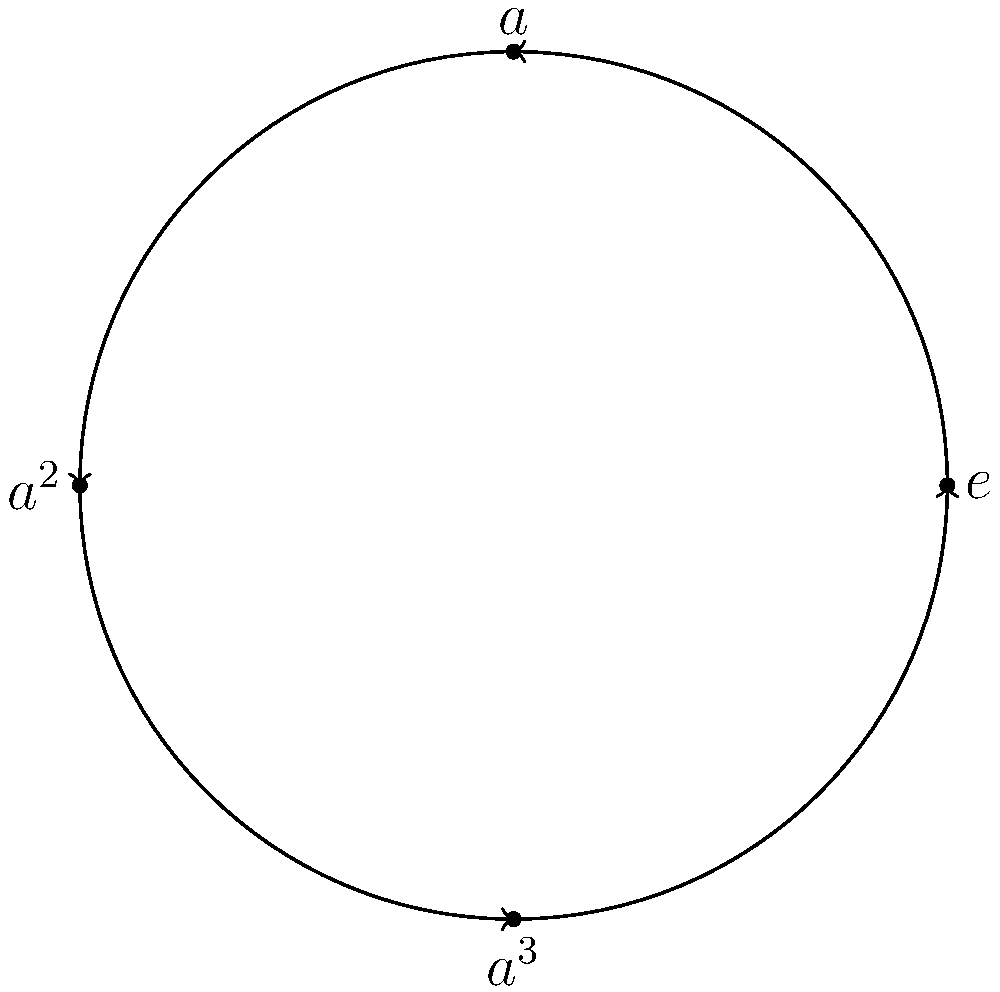In the context of improving user interface design for a group theory visualization tool, consider the circular diagram representing a cyclic group of order 4. If we apply the group operation three times starting from the identity element $e$, which element do we reach? How does this relate to the concept of generators in cyclic groups? To answer this question, let's follow these steps:

1. Understand the diagram:
   - The circle represents a cyclic group of order 4.
   - The elements are labeled $e$ (identity), $a$, $a^2$, and $a^3$.
   - The arrows indicate the group operation, moving clockwise.

2. Apply the group operation three times:
   - Start at $e$ (the identity element)
   - First application: $e \to a$
   - Second application: $a \to a^2$
   - Third application: $a^2 \to a^3$

3. Identify the final element:
   - After three applications, we reach $a^3$.

4. Relate to generators:
   - In a cyclic group, any element that can generate all other elements by repeated application is called a generator.
   - In this case, $a$ is a generator because:
     $a^1 = a$
     $a^2 = a \cdot a$
     $a^3 = a \cdot a \cdot a$
     $a^4 = a \cdot a \cdot a \cdot a = e$ (back to the identity)

5. User interface design implications:
   - This visualization helps users understand the structure of cyclic groups.
   - It illustrates how repeated application of the group operation relates to powers of the generator.
   - For UI/UX design, this could be enhanced with interactive elements, allowing users to click through the operations and see the results dynamically.
Answer: $a^3$ 